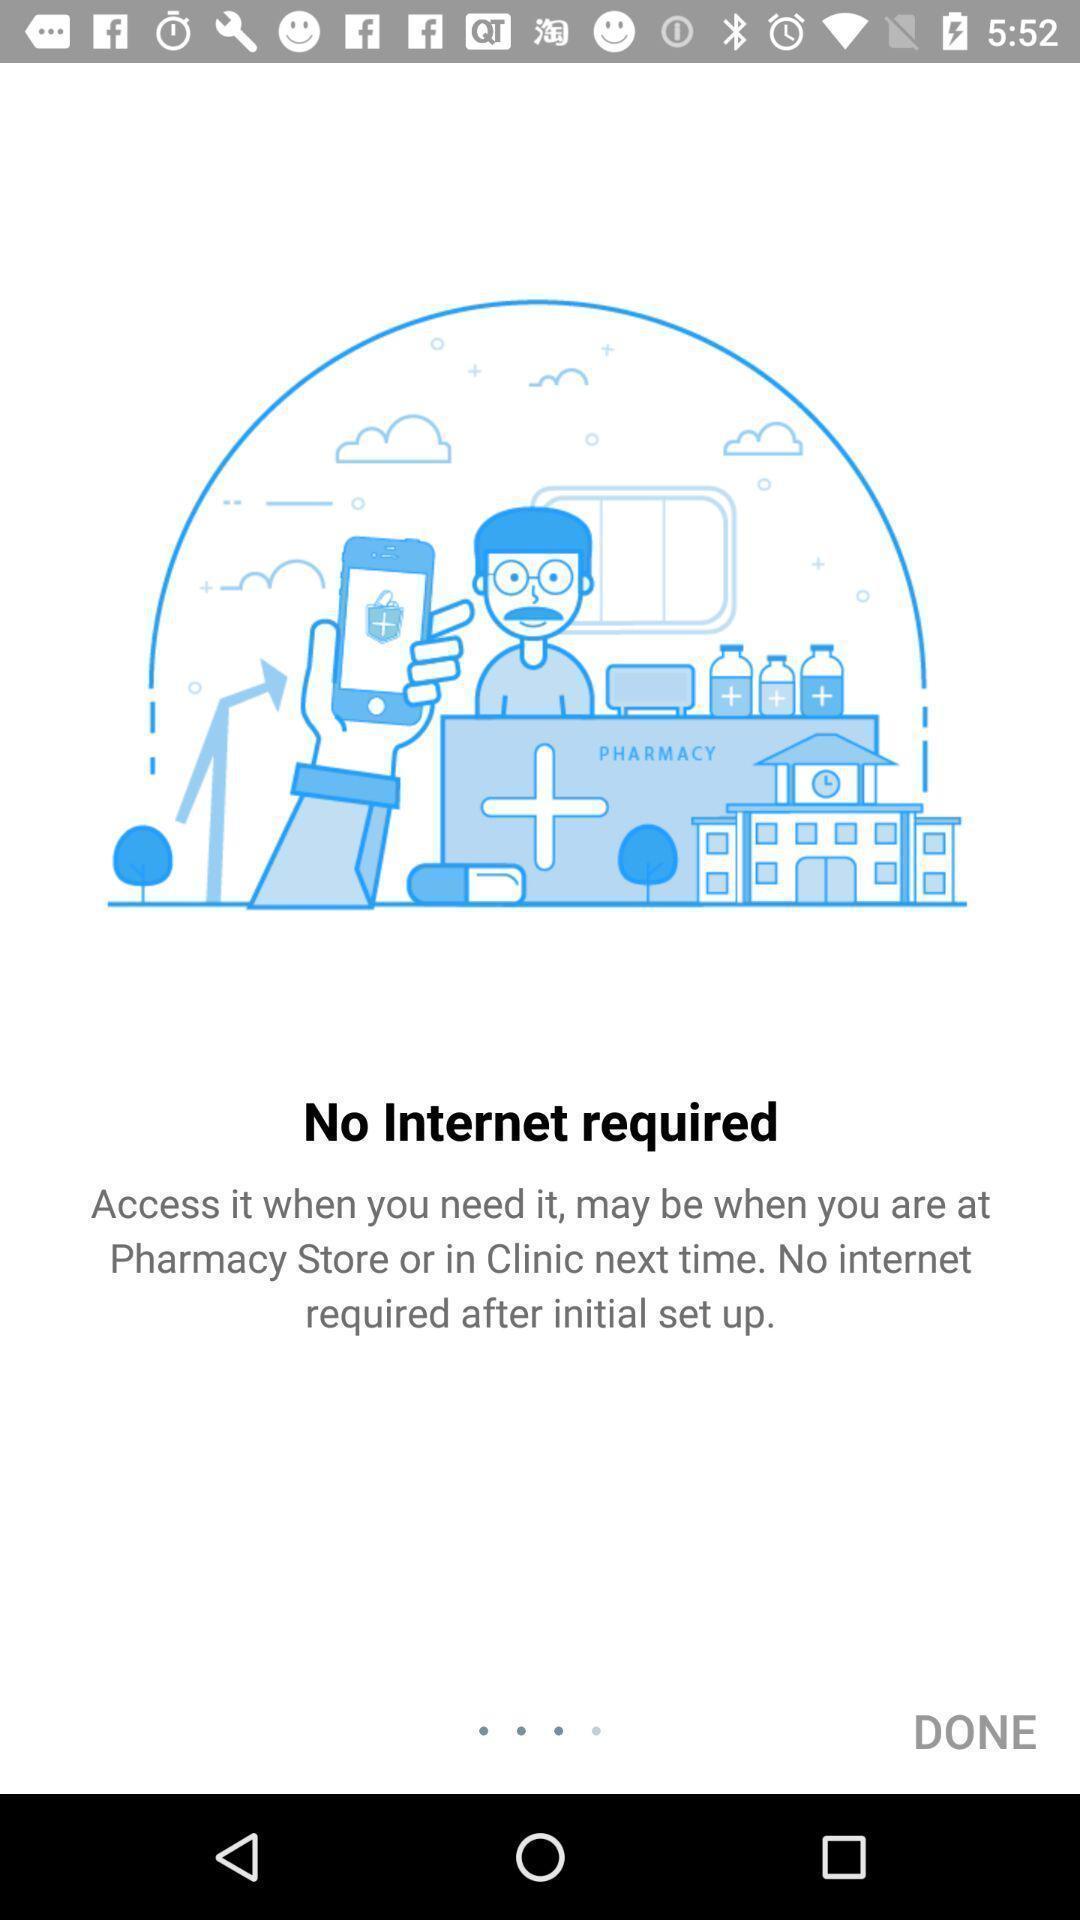Give me a summary of this screen capture. Page showing the guidelines for an app. 